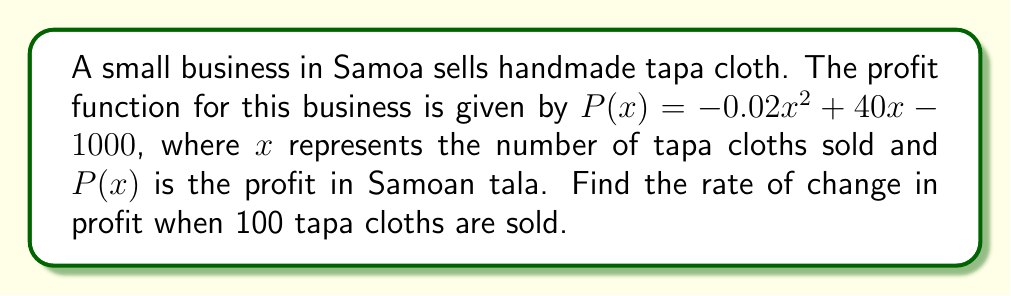Solve this math problem. To find the rate of change in profit, we need to calculate the derivative of the profit function and evaluate it at $x = 100$.

Step 1: Find the derivative of the profit function.
$$\frac{d}{dx}P(x) = \frac{d}{dx}(-0.02x^2 + 40x - 1000)$$
$$P'(x) = -0.04x + 40$$

Step 2: Evaluate the derivative at $x = 100$.
$$P'(100) = -0.04(100) + 40$$
$$P'(100) = -4 + 40 = 36$$

The rate of change in profit when 100 tapa cloths are sold is 36 Samoan tala per additional tapa cloth sold.
Answer: 36 tala per tapa cloth 